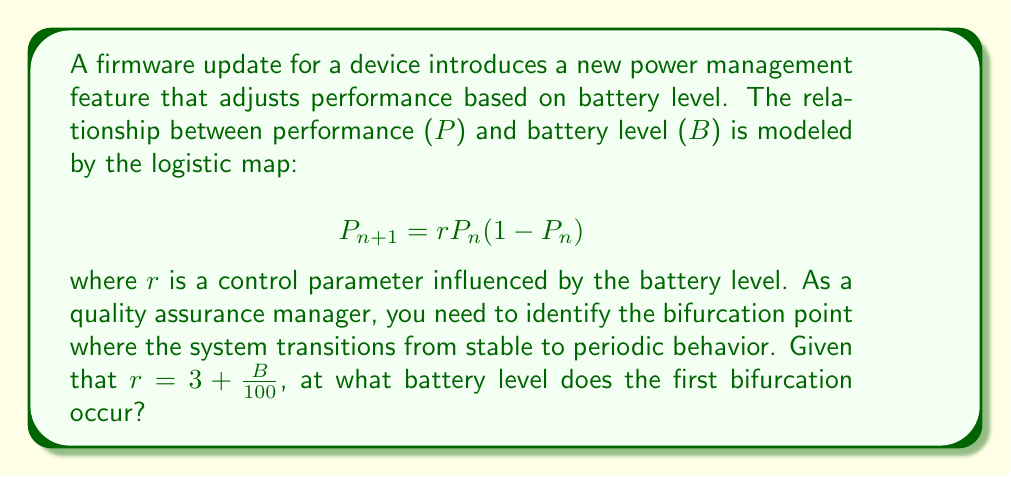Could you help me with this problem? To solve this problem, we need to follow these steps:

1. Recall that the logistic map undergoes its first bifurcation when $r = 3$.

2. We're given that $r = 3 + \frac{B}{100}$, where B is the battery level.

3. To find the bifurcation point, we need to solve:

   $$3 + \frac{B}{100} = 3$$

4. Simplifying:

   $$\frac{B}{100} = 0$$

5. Multiply both sides by 100:

   $$B = 0$$

This means that the first bifurcation occurs when the battery level is 0%.

6. However, since battery levels can't be negative in practical scenarios, we need to interpret this result carefully. It implies that the system is already in a periodic regime for any practical battery level.

7. To find the lowest practical battery level where the system is in a periodic regime, we need to consider the minimum possible battery level, which is typically around 1%.

Therefore, from a quality assurance perspective, we can conclude that the firmware exhibits periodic behavior for all practical battery levels, with the transition point occurring at the theoretical battery level of 0%.
Answer: 1% 